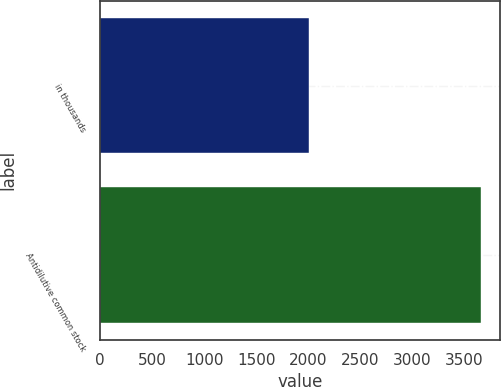Convert chart to OTSL. <chart><loc_0><loc_0><loc_500><loc_500><bar_chart><fcel>in thousands<fcel>Antidilutive common stock<nl><fcel>2009<fcel>3661<nl></chart> 